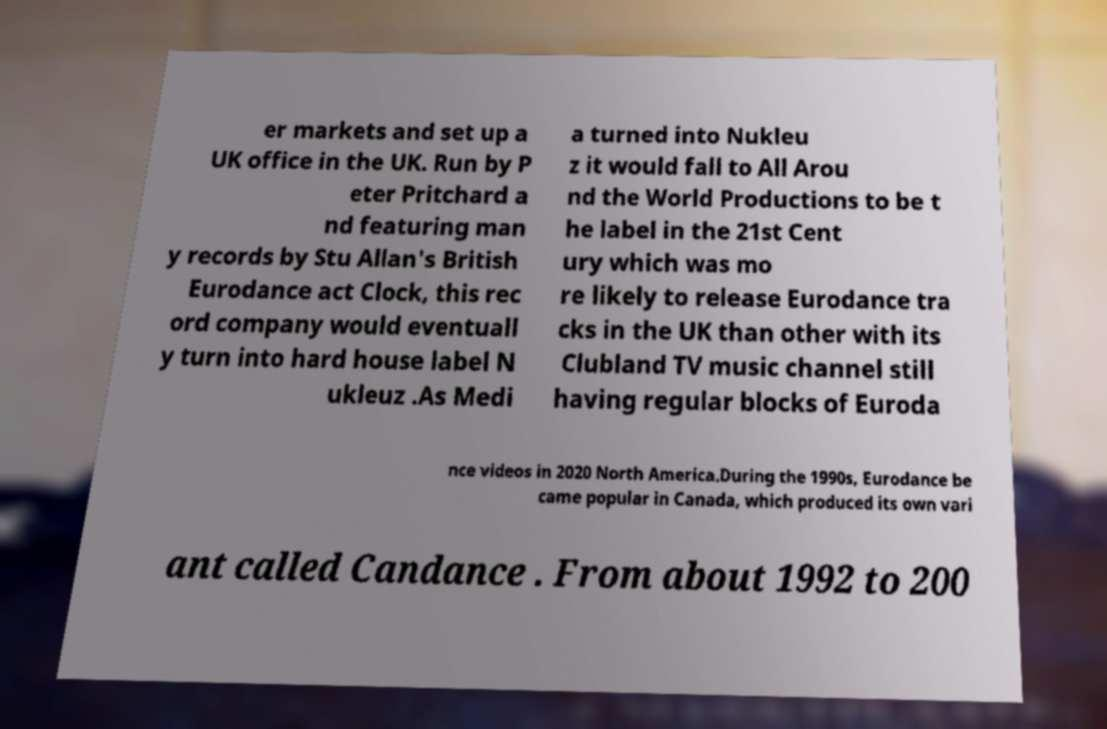Can you accurately transcribe the text from the provided image for me? er markets and set up a UK office in the UK. Run by P eter Pritchard a nd featuring man y records by Stu Allan's British Eurodance act Clock, this rec ord company would eventuall y turn into hard house label N ukleuz .As Medi a turned into Nukleu z it would fall to All Arou nd the World Productions to be t he label in the 21st Cent ury which was mo re likely to release Eurodance tra cks in the UK than other with its Clubland TV music channel still having regular blocks of Euroda nce videos in 2020 North America.During the 1990s, Eurodance be came popular in Canada, which produced its own vari ant called Candance . From about 1992 to 200 